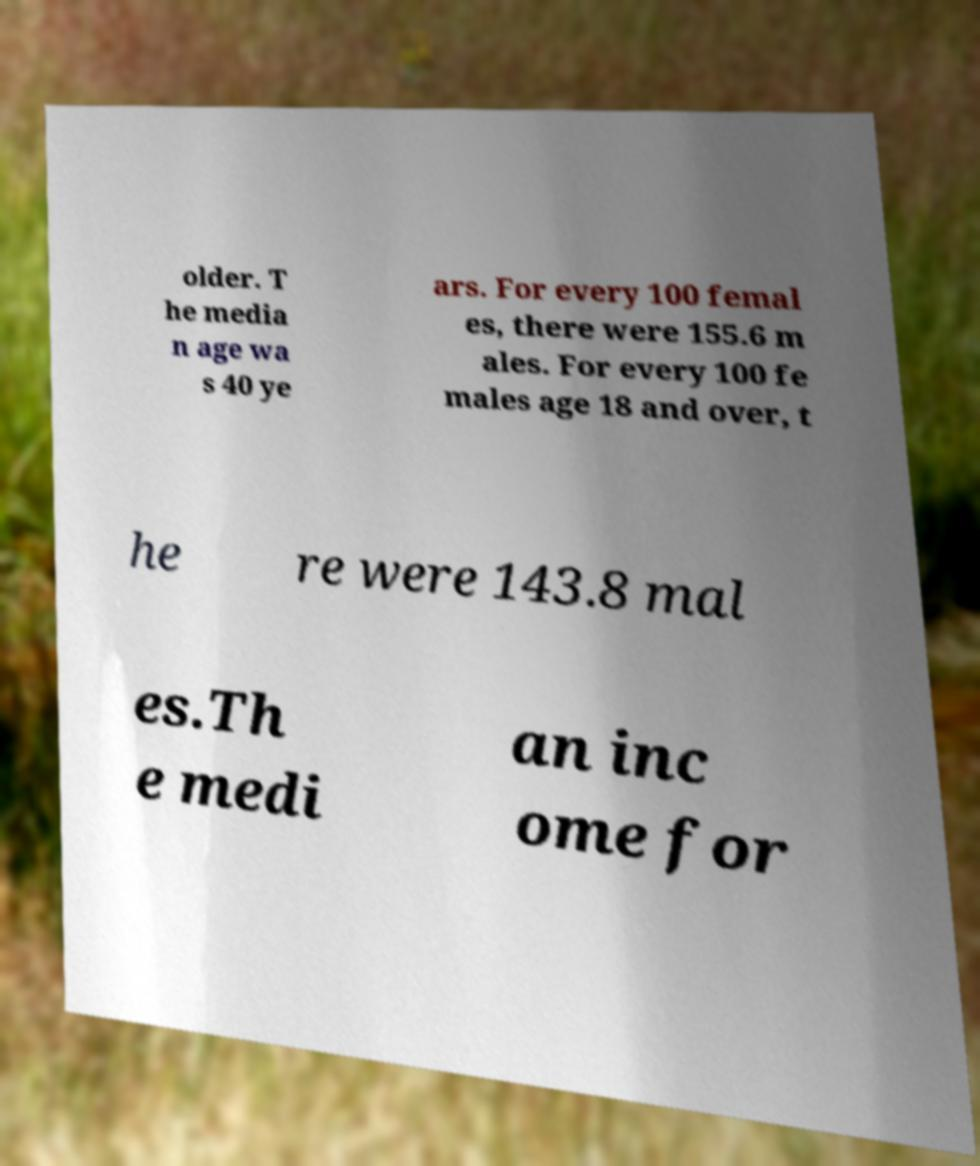Could you assist in decoding the text presented in this image and type it out clearly? older. T he media n age wa s 40 ye ars. For every 100 femal es, there were 155.6 m ales. For every 100 fe males age 18 and over, t he re were 143.8 mal es.Th e medi an inc ome for 